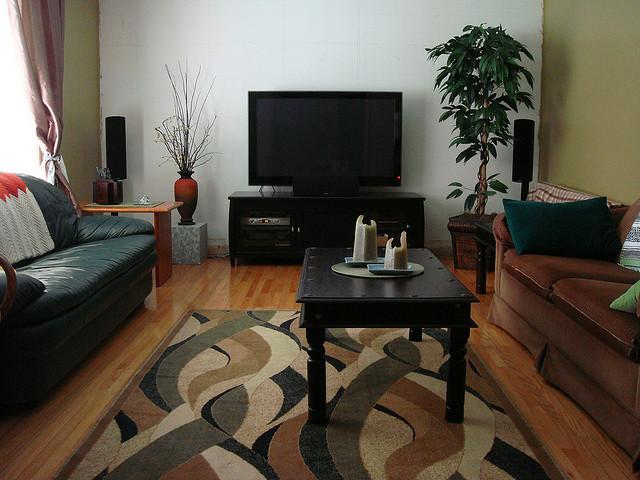What is in the middle of the table?
Answer briefly. Candles. What color is the carpet?
Keep it brief. Multi. Is the light on?
Be succinct. No. Is there a mirror in the room?
Concise answer only. No. Is there a desk in this room?
Answer briefly. No. What is the table made of?
Short answer required. Wood. What is the television set sitting on?
Be succinct. Stand. What is in the picture?
Answer briefly. Living room. Is the rug a floral design?
Give a very brief answer. No. Which color is dominant?
Keep it brief. Brown. Which room of the house is this?
Keep it brief. Living room. How many plants are pictured?
Concise answer only. 2. 